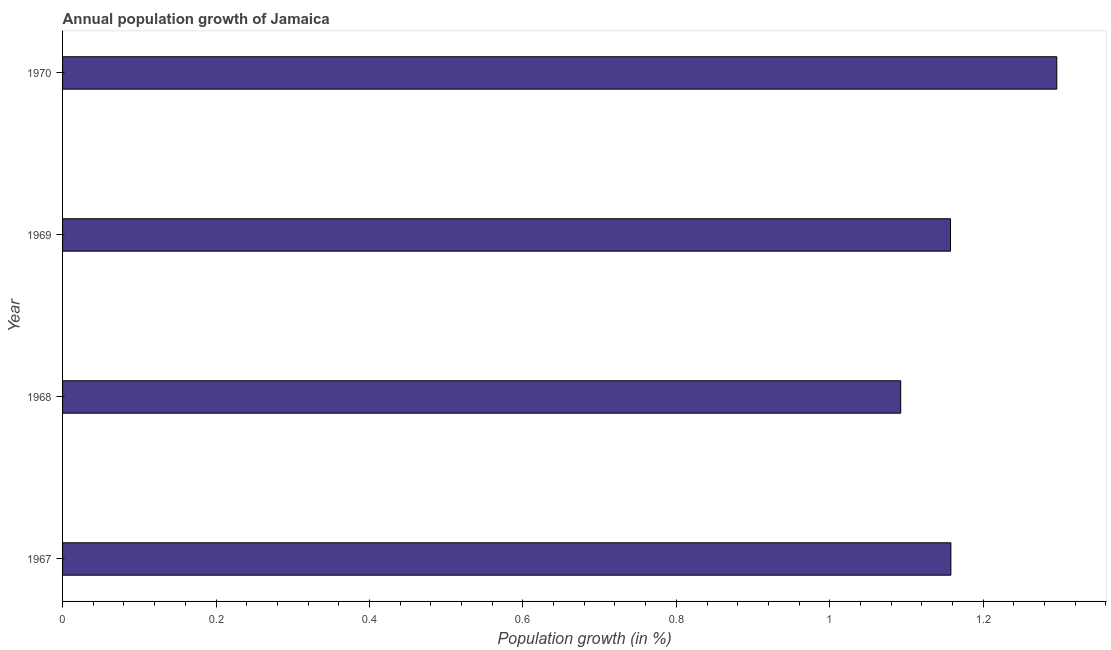Does the graph contain any zero values?
Offer a very short reply. No. What is the title of the graph?
Make the answer very short. Annual population growth of Jamaica. What is the label or title of the X-axis?
Offer a very short reply. Population growth (in %). What is the label or title of the Y-axis?
Offer a terse response. Year. What is the population growth in 1967?
Your answer should be very brief. 1.16. Across all years, what is the maximum population growth?
Make the answer very short. 1.3. Across all years, what is the minimum population growth?
Give a very brief answer. 1.09. In which year was the population growth maximum?
Your answer should be very brief. 1970. In which year was the population growth minimum?
Provide a succinct answer. 1968. What is the sum of the population growth?
Your answer should be compact. 4.7. What is the difference between the population growth in 1969 and 1970?
Keep it short and to the point. -0.14. What is the average population growth per year?
Provide a short and direct response. 1.18. What is the median population growth?
Ensure brevity in your answer.  1.16. Do a majority of the years between 1968 and 1969 (inclusive) have population growth greater than 0.56 %?
Make the answer very short. Yes. What is the ratio of the population growth in 1967 to that in 1969?
Offer a very short reply. 1. Is the population growth in 1967 less than that in 1969?
Keep it short and to the point. No. Is the difference between the population growth in 1967 and 1969 greater than the difference between any two years?
Make the answer very short. No. What is the difference between the highest and the second highest population growth?
Keep it short and to the point. 0.14. What is the difference between the highest and the lowest population growth?
Provide a short and direct response. 0.2. Are all the bars in the graph horizontal?
Keep it short and to the point. Yes. How many years are there in the graph?
Your answer should be compact. 4. What is the Population growth (in %) of 1967?
Offer a very short reply. 1.16. What is the Population growth (in %) of 1968?
Your answer should be compact. 1.09. What is the Population growth (in %) of 1969?
Keep it short and to the point. 1.16. What is the Population growth (in %) of 1970?
Keep it short and to the point. 1.3. What is the difference between the Population growth (in %) in 1967 and 1968?
Your answer should be very brief. 0.07. What is the difference between the Population growth (in %) in 1967 and 1969?
Your answer should be compact. 0. What is the difference between the Population growth (in %) in 1967 and 1970?
Provide a short and direct response. -0.14. What is the difference between the Population growth (in %) in 1968 and 1969?
Make the answer very short. -0.06. What is the difference between the Population growth (in %) in 1968 and 1970?
Your answer should be very brief. -0.2. What is the difference between the Population growth (in %) in 1969 and 1970?
Keep it short and to the point. -0.14. What is the ratio of the Population growth (in %) in 1967 to that in 1968?
Your answer should be very brief. 1.06. What is the ratio of the Population growth (in %) in 1967 to that in 1969?
Keep it short and to the point. 1. What is the ratio of the Population growth (in %) in 1967 to that in 1970?
Ensure brevity in your answer.  0.89. What is the ratio of the Population growth (in %) in 1968 to that in 1969?
Give a very brief answer. 0.94. What is the ratio of the Population growth (in %) in 1968 to that in 1970?
Your answer should be compact. 0.84. What is the ratio of the Population growth (in %) in 1969 to that in 1970?
Keep it short and to the point. 0.89. 